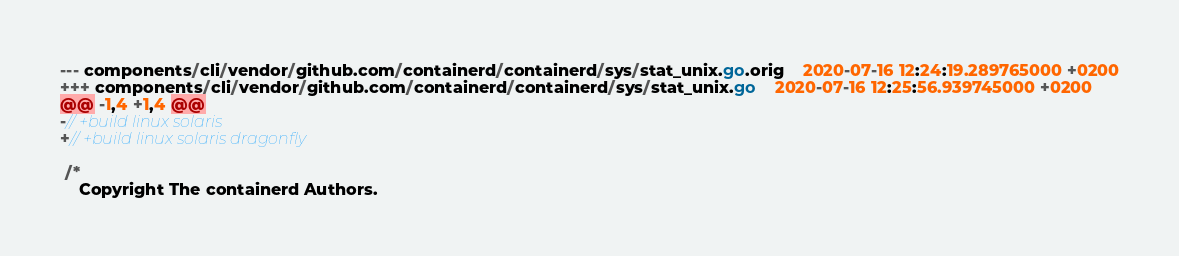<code> <loc_0><loc_0><loc_500><loc_500><_Go_>--- components/cli/vendor/github.com/containerd/containerd/sys/stat_unix.go.orig	2020-07-16 12:24:19.289765000 +0200
+++ components/cli/vendor/github.com/containerd/containerd/sys/stat_unix.go	2020-07-16 12:25:56.939745000 +0200
@@ -1,4 +1,4 @@
-// +build linux solaris
+// +build linux solaris dragonfly
 
 /*
    Copyright The containerd Authors.
</code> 